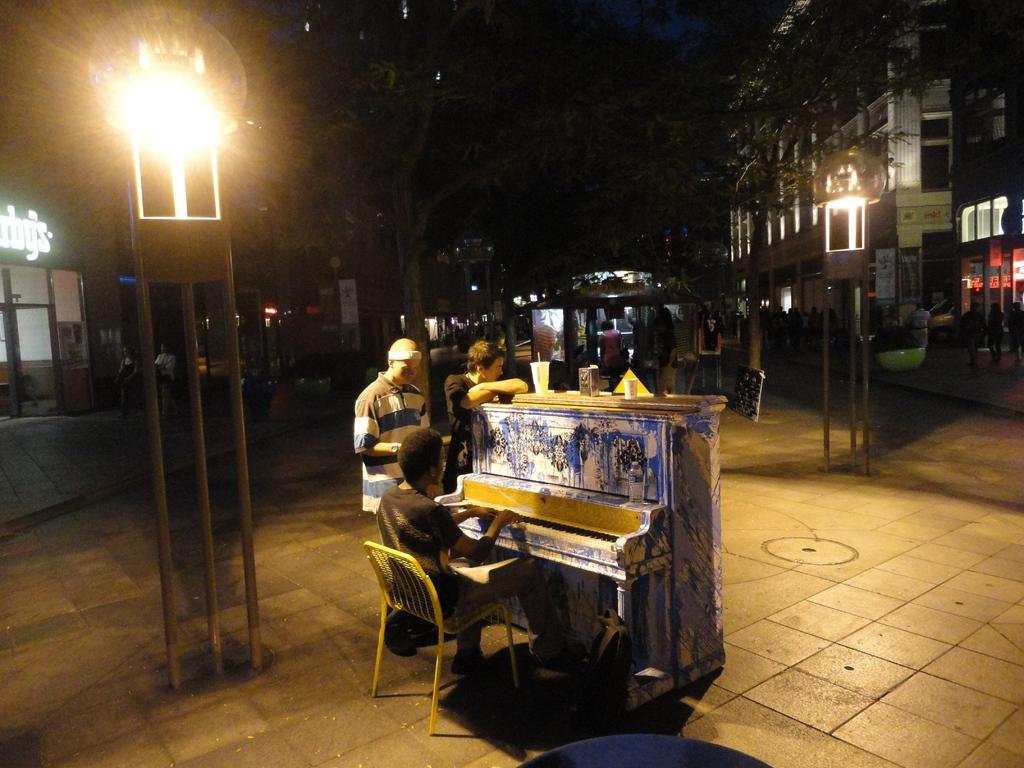What is the person in the image doing? The person is sitting on a chair and playing a piano in the image. What objects can be seen near the person? There are glasses visible in the image. How many men are standing in the image? There are two men standing on the ground in the image. What type of vegetation is present in the image? There are trees in the image. What type of structures are visible in the image? There are buildings in the image. How would you describe the lighting in the image? The background of the image is dark. What degree does the person playing the piano have in the image? There is no information about the person's degree in the image. Is there any water visible in the image? No, there is no water present in the image. 